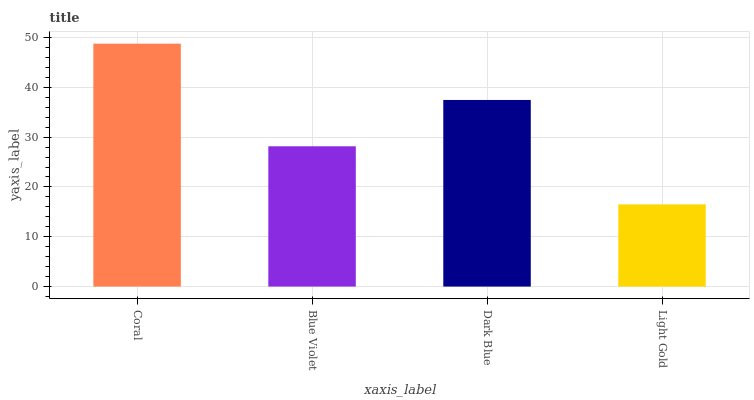Is Light Gold the minimum?
Answer yes or no. Yes. Is Coral the maximum?
Answer yes or no. Yes. Is Blue Violet the minimum?
Answer yes or no. No. Is Blue Violet the maximum?
Answer yes or no. No. Is Coral greater than Blue Violet?
Answer yes or no. Yes. Is Blue Violet less than Coral?
Answer yes or no. Yes. Is Blue Violet greater than Coral?
Answer yes or no. No. Is Coral less than Blue Violet?
Answer yes or no. No. Is Dark Blue the high median?
Answer yes or no. Yes. Is Blue Violet the low median?
Answer yes or no. Yes. Is Light Gold the high median?
Answer yes or no. No. Is Dark Blue the low median?
Answer yes or no. No. 